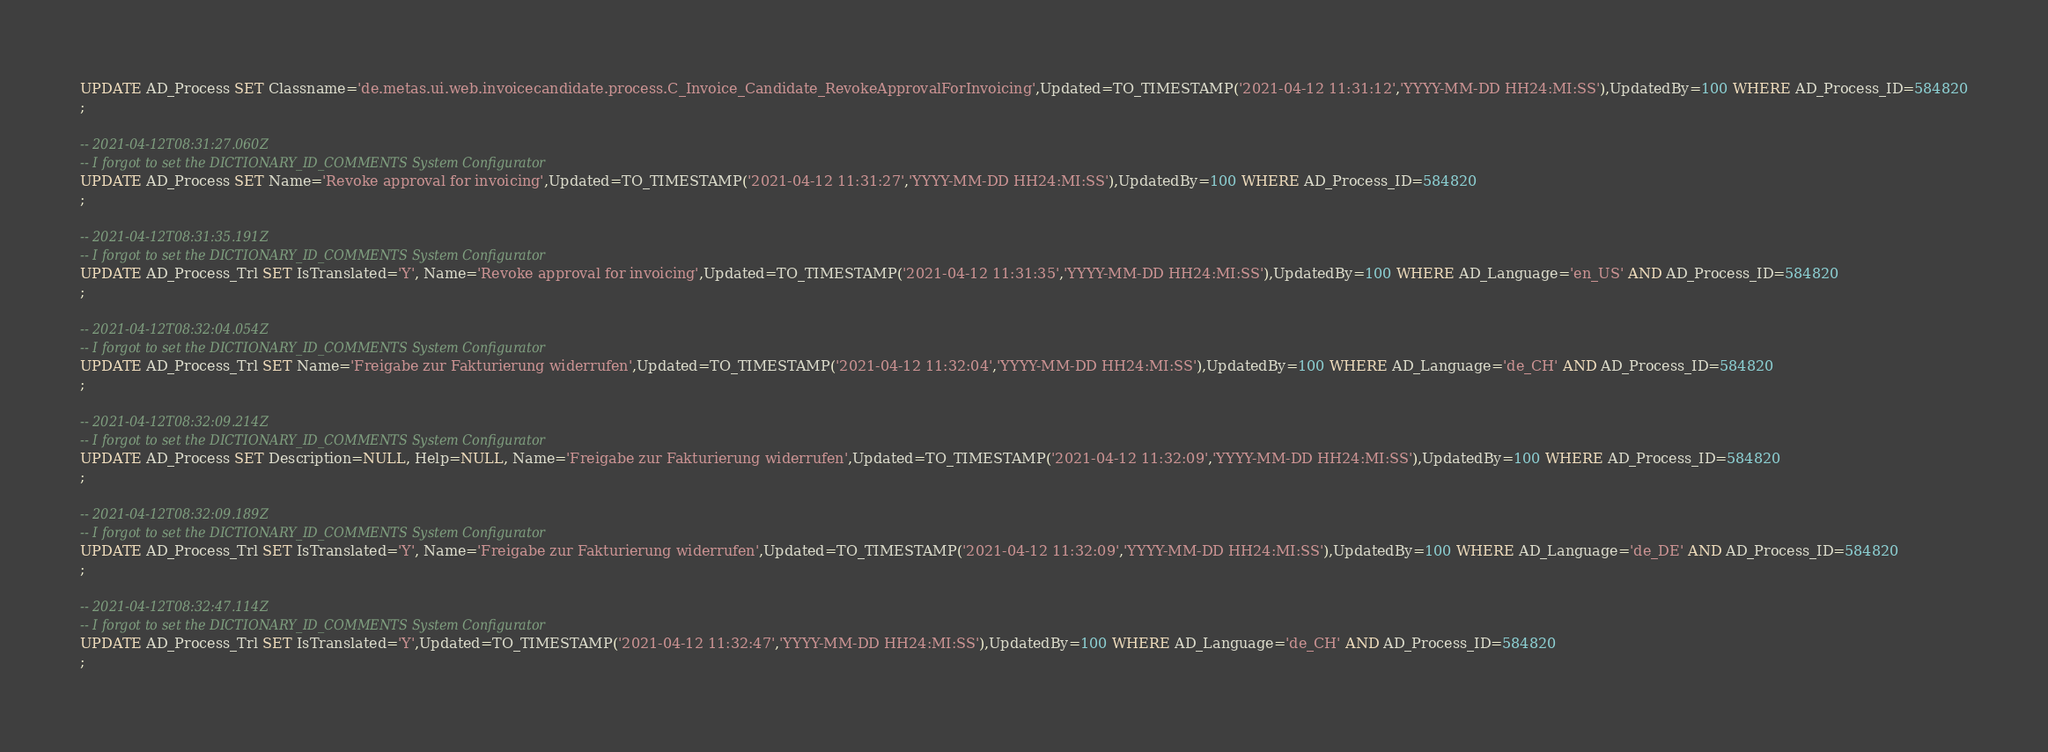<code> <loc_0><loc_0><loc_500><loc_500><_SQL_>UPDATE AD_Process SET Classname='de.metas.ui.web.invoicecandidate.process.C_Invoice_Candidate_RevokeApprovalForInvoicing',Updated=TO_TIMESTAMP('2021-04-12 11:31:12','YYYY-MM-DD HH24:MI:SS'),UpdatedBy=100 WHERE AD_Process_ID=584820
;

-- 2021-04-12T08:31:27.060Z
-- I forgot to set the DICTIONARY_ID_COMMENTS System Configurator
UPDATE AD_Process SET Name='Revoke approval for invoicing',Updated=TO_TIMESTAMP('2021-04-12 11:31:27','YYYY-MM-DD HH24:MI:SS'),UpdatedBy=100 WHERE AD_Process_ID=584820
;

-- 2021-04-12T08:31:35.191Z
-- I forgot to set the DICTIONARY_ID_COMMENTS System Configurator
UPDATE AD_Process_Trl SET IsTranslated='Y', Name='Revoke approval for invoicing',Updated=TO_TIMESTAMP('2021-04-12 11:31:35','YYYY-MM-DD HH24:MI:SS'),UpdatedBy=100 WHERE AD_Language='en_US' AND AD_Process_ID=584820
;

-- 2021-04-12T08:32:04.054Z
-- I forgot to set the DICTIONARY_ID_COMMENTS System Configurator
UPDATE AD_Process_Trl SET Name='Freigabe zur Fakturierung widerrufen',Updated=TO_TIMESTAMP('2021-04-12 11:32:04','YYYY-MM-DD HH24:MI:SS'),UpdatedBy=100 WHERE AD_Language='de_CH' AND AD_Process_ID=584820
;

-- 2021-04-12T08:32:09.214Z
-- I forgot to set the DICTIONARY_ID_COMMENTS System Configurator
UPDATE AD_Process SET Description=NULL, Help=NULL, Name='Freigabe zur Fakturierung widerrufen',Updated=TO_TIMESTAMP('2021-04-12 11:32:09','YYYY-MM-DD HH24:MI:SS'),UpdatedBy=100 WHERE AD_Process_ID=584820
;

-- 2021-04-12T08:32:09.189Z
-- I forgot to set the DICTIONARY_ID_COMMENTS System Configurator
UPDATE AD_Process_Trl SET IsTranslated='Y', Name='Freigabe zur Fakturierung widerrufen',Updated=TO_TIMESTAMP('2021-04-12 11:32:09','YYYY-MM-DD HH24:MI:SS'),UpdatedBy=100 WHERE AD_Language='de_DE' AND AD_Process_ID=584820
;

-- 2021-04-12T08:32:47.114Z
-- I forgot to set the DICTIONARY_ID_COMMENTS System Configurator
UPDATE AD_Process_Trl SET IsTranslated='Y',Updated=TO_TIMESTAMP('2021-04-12 11:32:47','YYYY-MM-DD HH24:MI:SS'),UpdatedBy=100 WHERE AD_Language='de_CH' AND AD_Process_ID=584820
;

</code> 